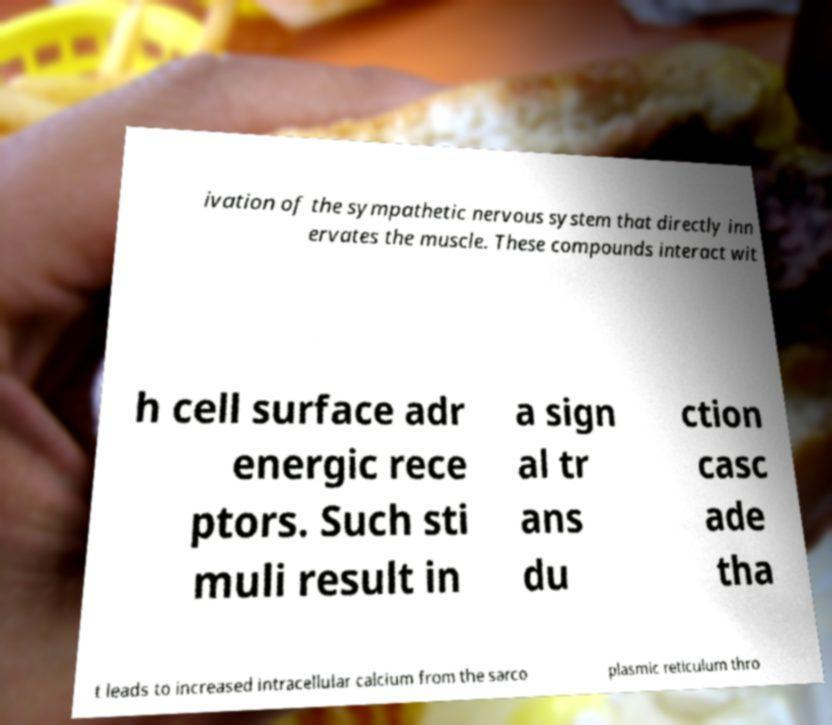Could you extract and type out the text from this image? ivation of the sympathetic nervous system that directly inn ervates the muscle. These compounds interact wit h cell surface adr energic rece ptors. Such sti muli result in a sign al tr ans du ction casc ade tha t leads to increased intracellular calcium from the sarco plasmic reticulum thro 